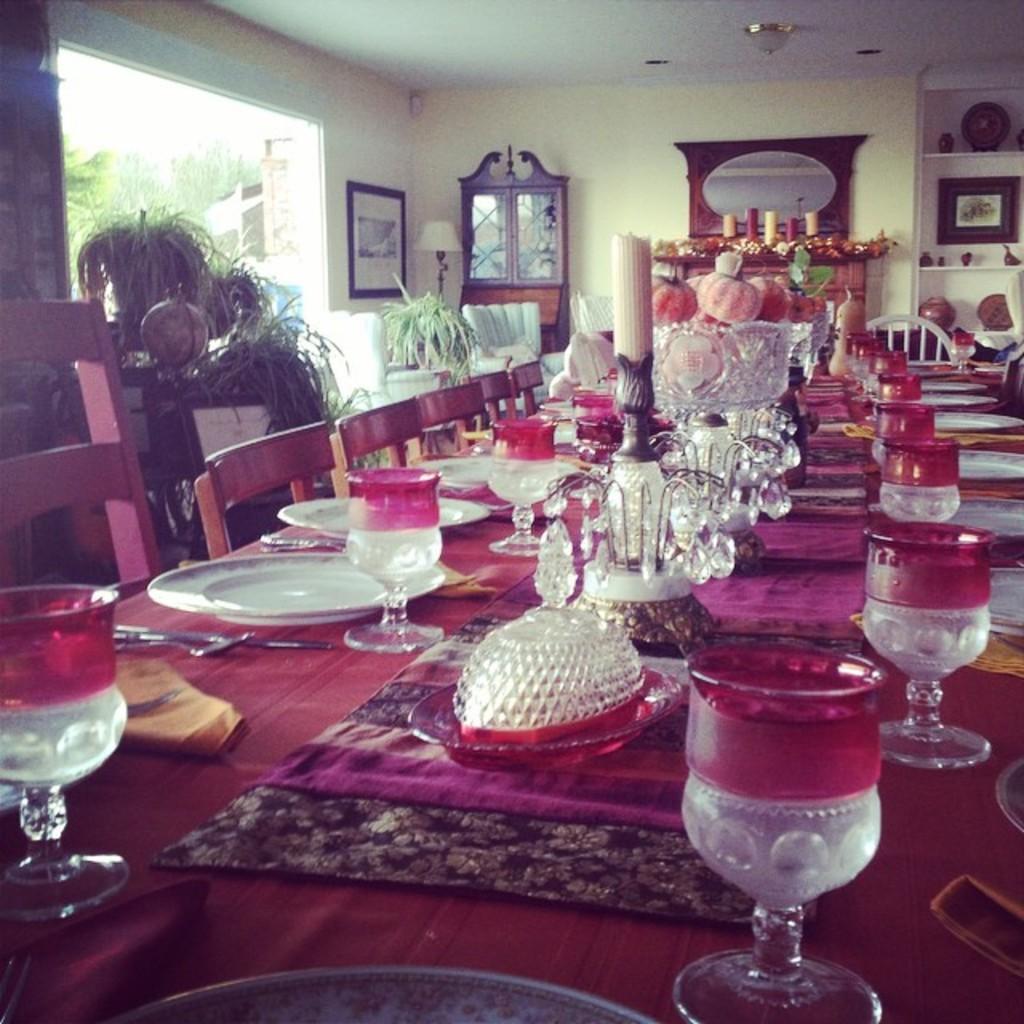Describe this image in one or two sentences. In this image we can see there are plates, glasses, candles, food items and a few other on the dining table, in front of it there are chairs and in the background there are plants, photo frames, cupboards, a window and many other objects. 